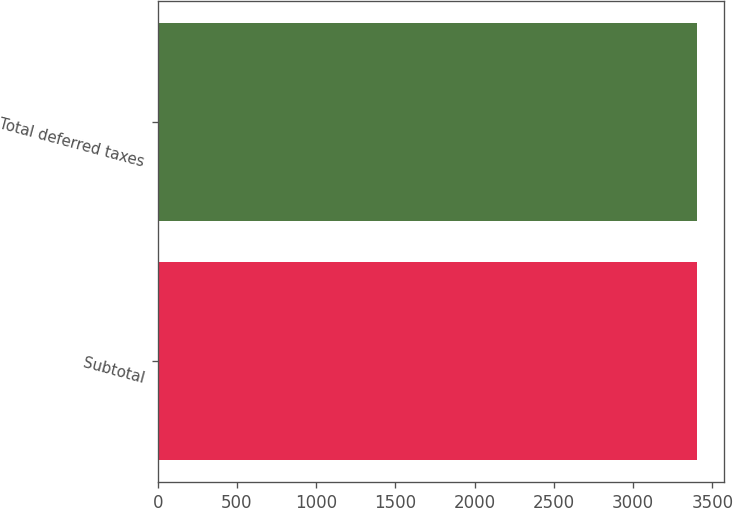<chart> <loc_0><loc_0><loc_500><loc_500><bar_chart><fcel>Subtotal<fcel>Total deferred taxes<nl><fcel>3403<fcel>3403.1<nl></chart> 